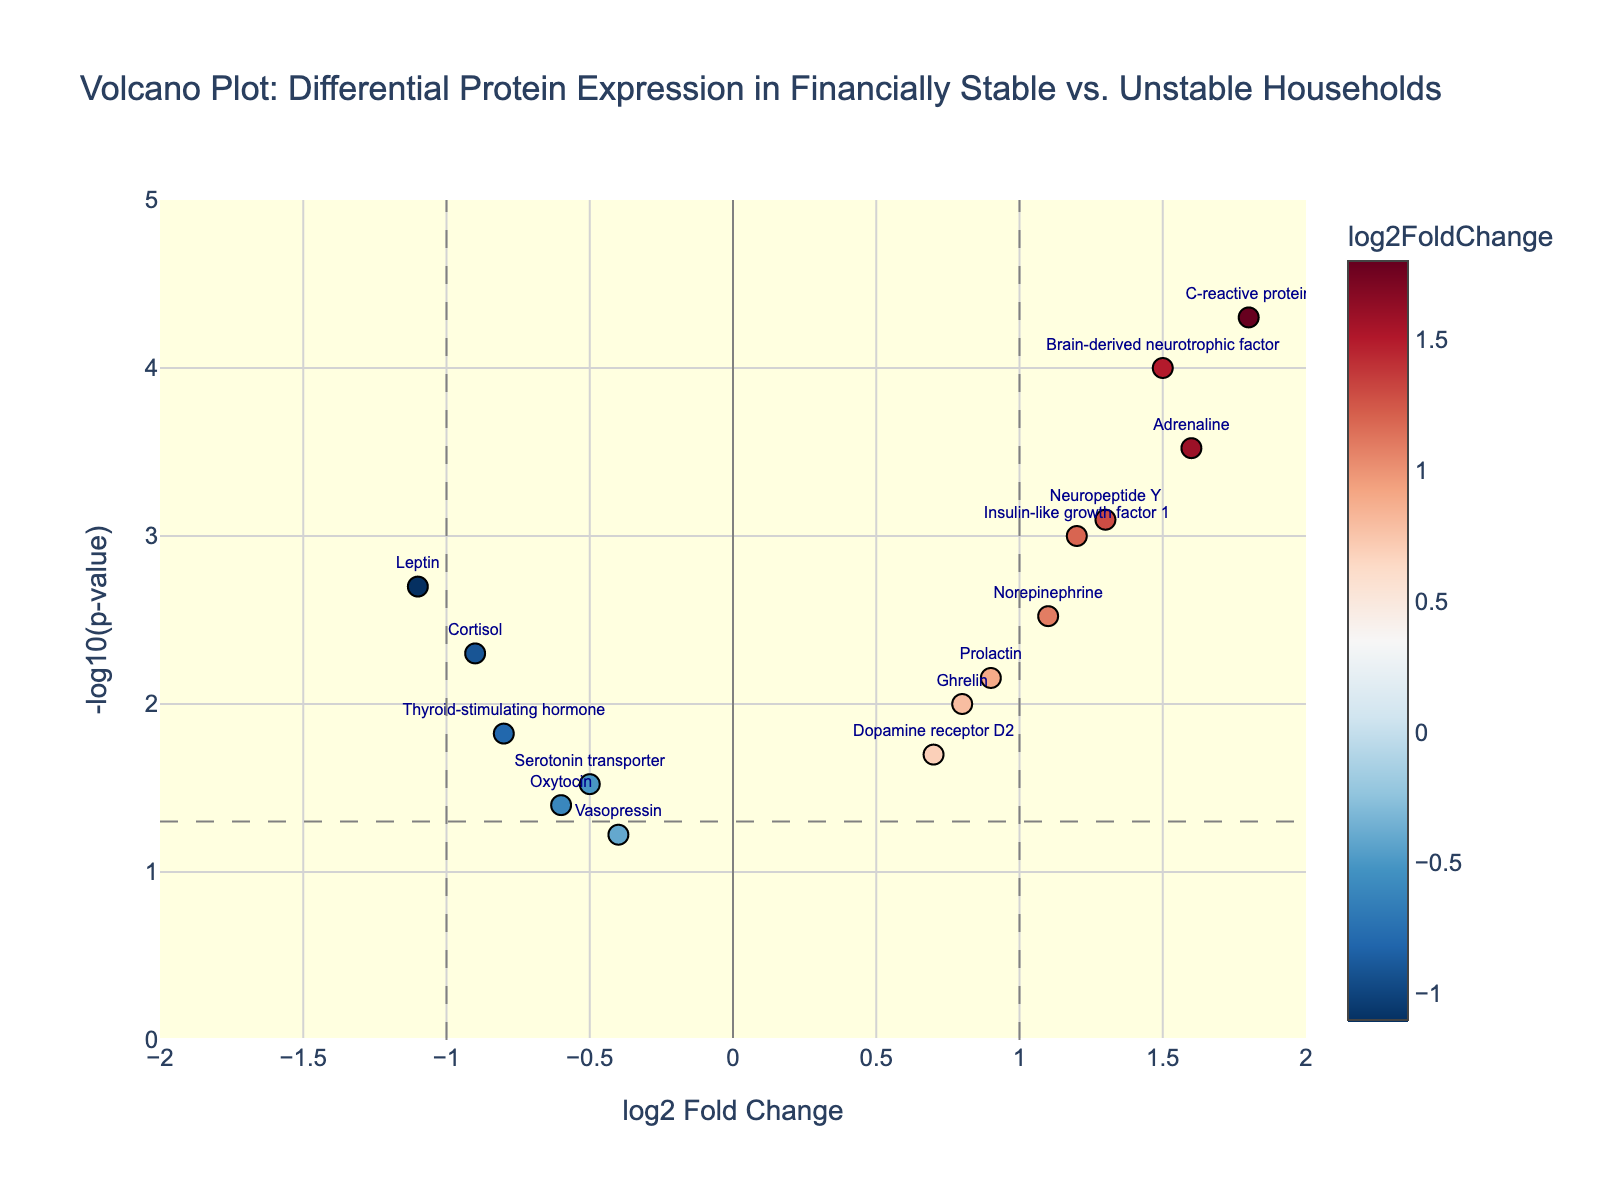What is the title of the plot? The title is usually placed prominently at the top of the plot and is easy to read. It generally provides a quick summary of what the plot represents.
Answer: Volcano Plot: Differential Protein Expression in Financially Stable vs. Unstable Households What are the x-axis and y-axis representing? The axes labels typically describe the variables being plotted. Here, the x-axis label 'log2 Fold Change' indicates the fold change in protein expression, and the y-axis label '-log10(p-value)' represents the transformed p-value to signify statistical significance.
Answer: The x-axis is 'log2 Fold Change', and the y-axis is '-log10(p-value)' Which protein has the highest -log10(pValue)? By scanning the y-axis for the highest point and finding the corresponding text label, you can determine which protein has the highest statistical significance.
Answer: C-reactive protein Which protein shows the largest positive fold change? We can locate the point farthest to the right on the x-axis and check the text label to find the protein with the largest positive log2 fold change.
Answer: C-reactive protein How many proteins have a statistically significant p-value (< 0.05)? A horizontal line at -log10(0.05) helps identify the threshold of significance. Proteins above this line have p-values < 0.05. Count these points to get the answer.
Answer: Twelve proteins Which proteins exhibit a negative fold change and are statistically significant (p < 0.05)? Focus on the left side of the plot (negative fold change), and check which points are above the significance threshold line.
Answer: Cortisol, Leptin, Thyroid-stimulating hormone Which proteins show both a log2 fold change greater than 1 and a p-value below 0.0005? Identify points to the right of x = 1 and above y = -log10(0.0005), then check their text labels.
Answer: C-reactive protein, Adrenaline What does the color scale in the plot represent? The color bar along with the scatter points in the plot indicates the variable it's mapping, typically explained in the guide or legend. This plot maps log2FoldChange.
Answer: log2FoldChange How many proteins have a log2 fold change between -0.5 and 0.5? Count the points within the range -0.5 to 0.5 along the x-axis. These points represent proteins with small fold changes.
Answer: Three proteins Which proteins are on the threshold lines for log2 fold change and p-value? Identify the points that precisely lie on x = -1, x = 1, and y = -log10(0.05) thresholds to see the boundary conditions.
Answer: Leptin (x = -1), Norepinephrine (x = 1), Serotonin transporter (y = -log10(0.05)) 